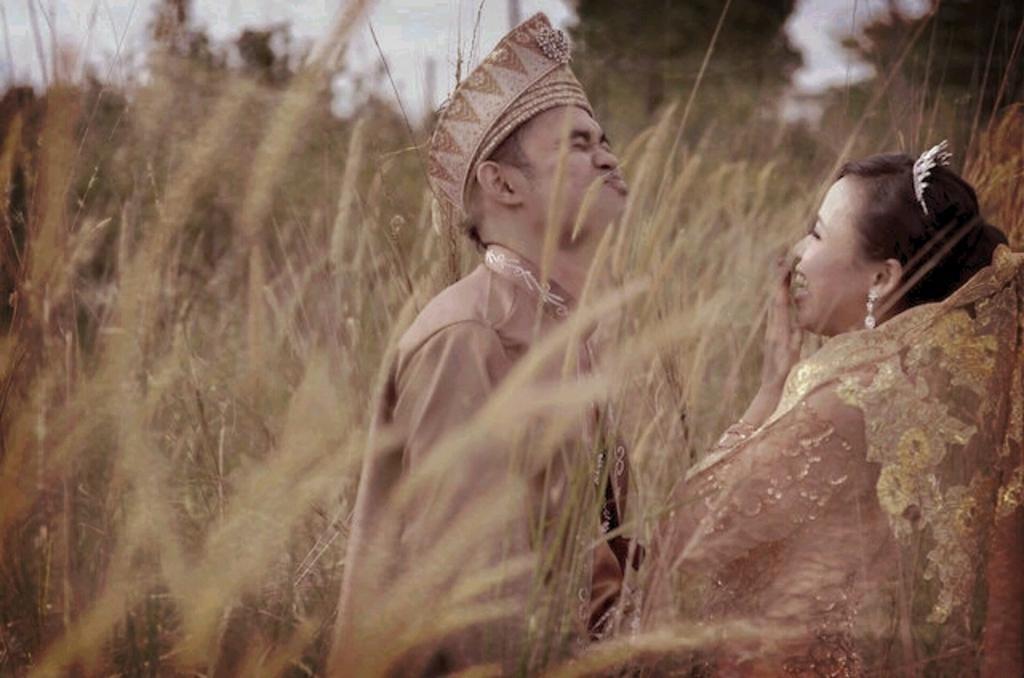How would you summarize this image in a sentence or two? In the middle of the image two persons are standing and smiling. Behind them there is grass and there are some trees. At the top of the image there is sky. 